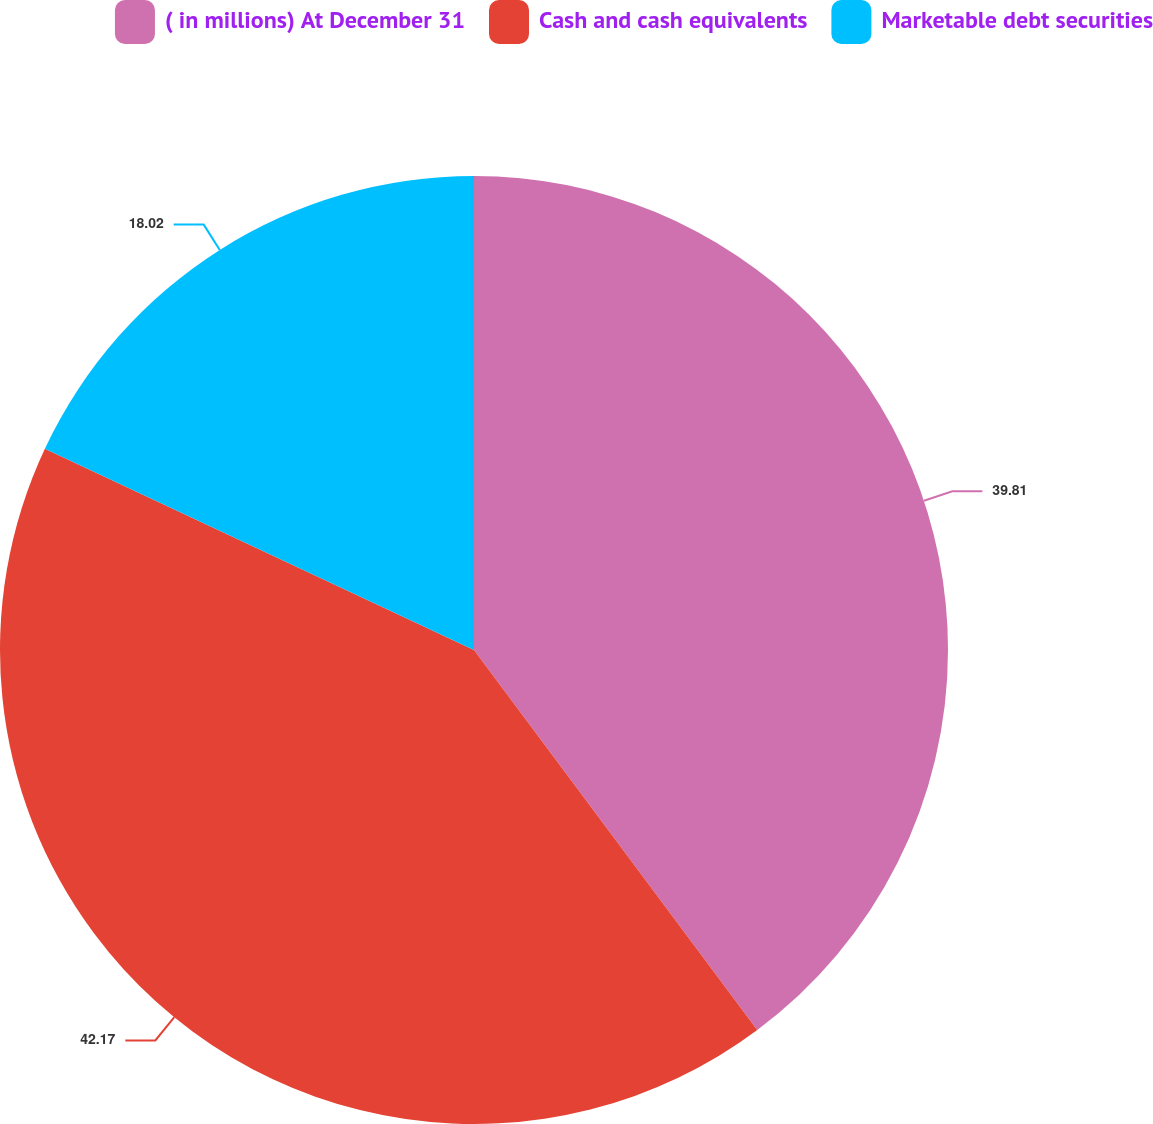Convert chart. <chart><loc_0><loc_0><loc_500><loc_500><pie_chart><fcel>( in millions) At December 31<fcel>Cash and cash equivalents<fcel>Marketable debt securities<nl><fcel>39.81%<fcel>42.18%<fcel>18.02%<nl></chart> 